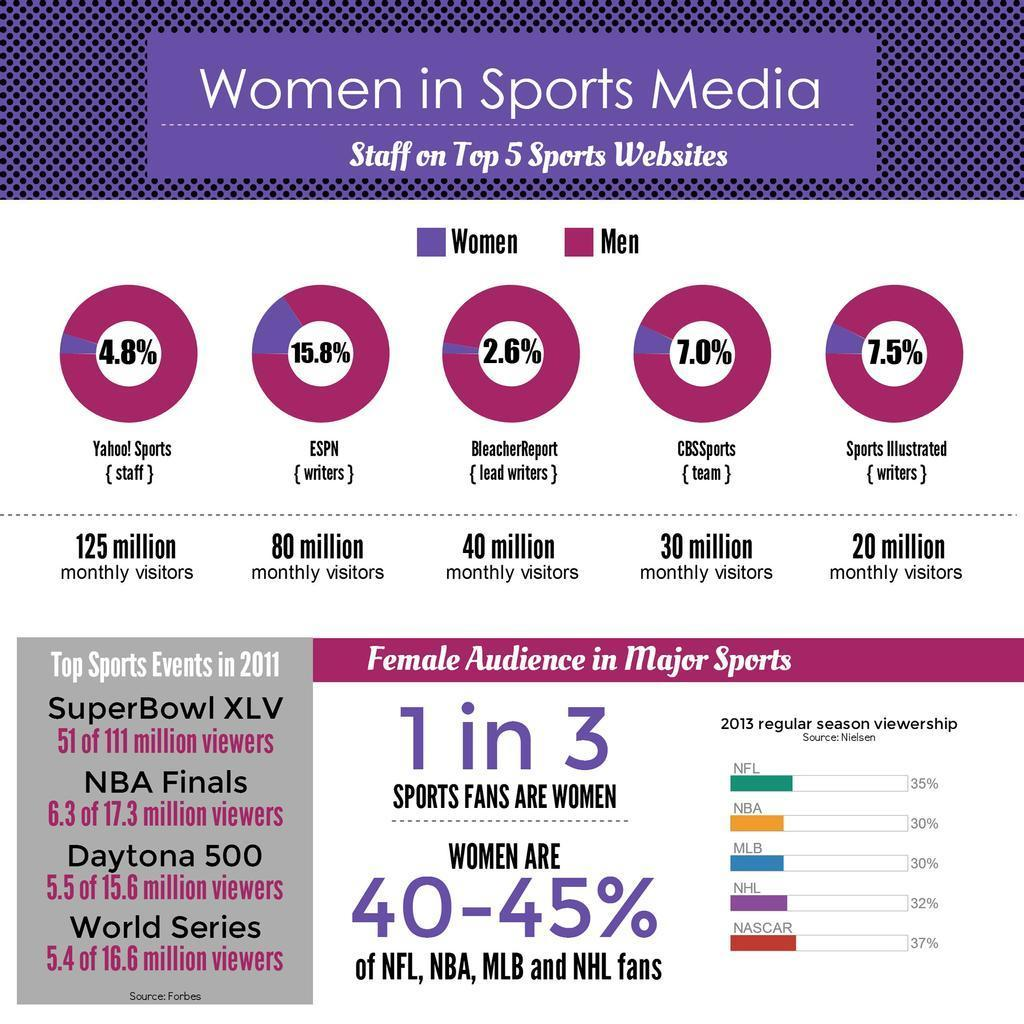What percentage of women work as writers in ESPN, 15.8%, 2.6%, or & 7.5%?
Answer the question with a short phrase. 15.8% What is the percentage of lead men writers in BleacherReport? 97.4% 